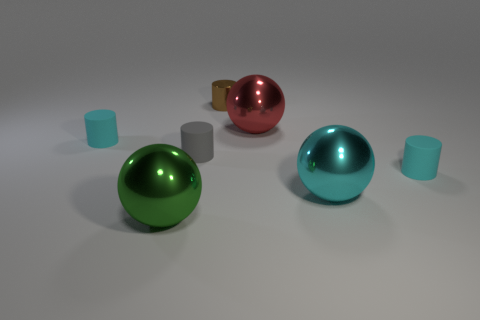Subtract all large red spheres. How many spheres are left? 2 Add 1 gray rubber cylinders. How many objects exist? 8 Subtract 3 cylinders. How many cylinders are left? 1 Subtract all red balls. How many balls are left? 2 Subtract all cylinders. How many objects are left? 3 Subtract all yellow balls. How many blue cylinders are left? 0 Subtract 0 yellow cylinders. How many objects are left? 7 Subtract all red cylinders. Subtract all cyan blocks. How many cylinders are left? 4 Subtract all large brown matte objects. Subtract all brown objects. How many objects are left? 6 Add 2 small brown shiny objects. How many small brown shiny objects are left? 3 